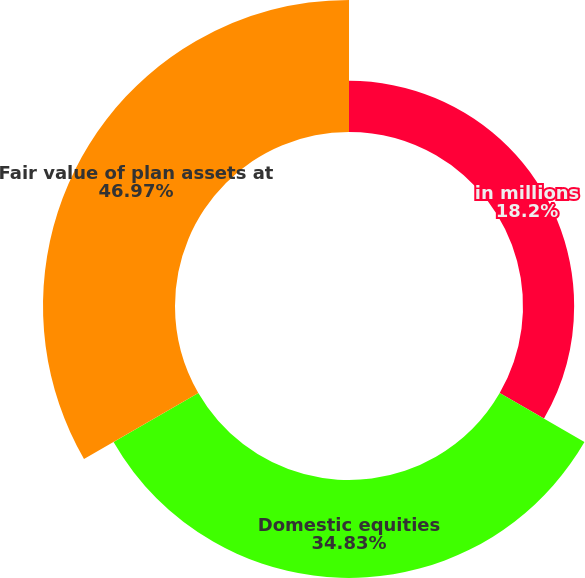<chart> <loc_0><loc_0><loc_500><loc_500><pie_chart><fcel>in millions<fcel>Domestic equities<fcel>Fair value of plan assets at<nl><fcel>18.2%<fcel>34.83%<fcel>46.97%<nl></chart> 